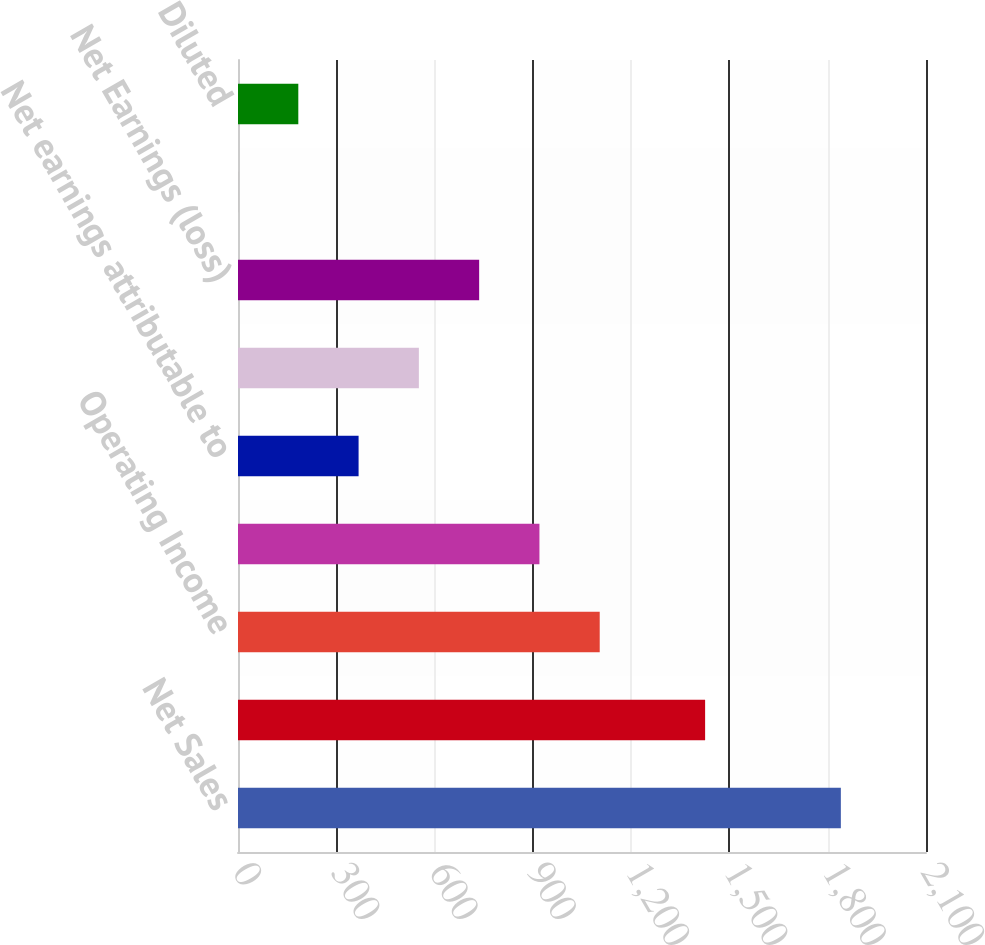Convert chart. <chart><loc_0><loc_0><loc_500><loc_500><bar_chart><fcel>Net Sales<fcel>gross Profit<fcel>Operating Income<fcel>Net Earnings Attributable to<fcel>Net earnings attributable to<fcel>Operating Income (loss)<fcel>Net Earnings (loss)<fcel>Basic<fcel>Diluted<nl><fcel>1840.1<fcel>1425.8<fcel>1104.09<fcel>920.09<fcel>368.09<fcel>552.09<fcel>736.09<fcel>0.09<fcel>184.09<nl></chart> 